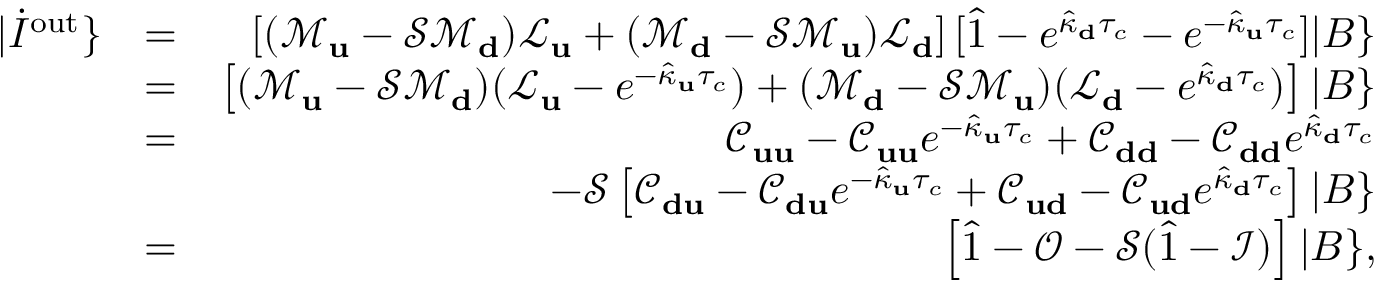Convert formula to latex. <formula><loc_0><loc_0><loc_500><loc_500>\begin{array} { r l r } { | \dot { I } ^ { o u t } \} } & { = } & { \left [ ( \mathcal { M } _ { u } - \mathcal { S } \mathcal { M } _ { d } ) \mathcal { L } _ { u } + ( \mathcal { M } _ { d } - \mathcal { S } \mathcal { M } _ { u } ) \mathcal { L } _ { d } \right ] [ \hat { 1 } - e ^ { \hat { \kappa } _ { d } \tau _ { c } } - e ^ { - \hat { \kappa } _ { u } \tau _ { c } } ] | B \} } \\ & { = } & { \left [ ( \mathcal { M } _ { u } - \mathcal { S } \mathcal { M } _ { d } ) ( \mathcal { L } _ { u } - e ^ { - \hat { \kappa } _ { u } \tau _ { c } } ) + ( \mathcal { M } _ { d } - \mathcal { S } \mathcal { M } _ { u } ) ( \mathcal { L } _ { d } - e ^ { \hat { \kappa } _ { d } \tau _ { c } } ) \right ] | B \} } \\ & { = } & { \mathcal { C } _ { u u } - \mathcal { C } _ { u u } e ^ { - \hat { \kappa } _ { u } \tau _ { c } } + \mathcal { C } _ { d d } - \mathcal { C } _ { d d } e ^ { \hat { \kappa } _ { d } \tau _ { c } } } \\ & { - \mathcal { S } \left [ \mathcal { C } _ { d u } - \mathcal { C } _ { d u } e ^ { - \hat { \kappa } _ { u } \tau _ { c } } + \mathcal { C } _ { u d } - \mathcal { C } _ { u d } e ^ { \hat { \kappa } _ { d } \tau _ { c } } \right ] | B \} } \\ & { = } & { \left [ \hat { 1 } - \mathcal { O } - \mathcal { S } ( \hat { 1 } - \mathcal { I } ) \right ] | B \} , } \end{array}</formula> 